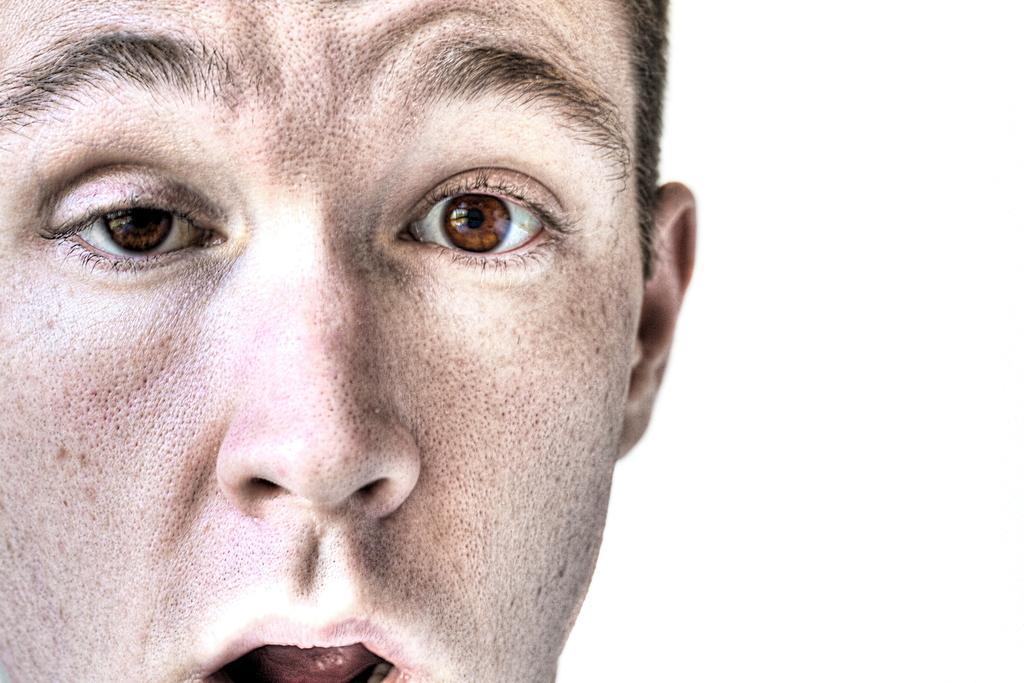Could you give a brief overview of what you see in this image? In this image I can see a person's face. The background is white in color. This image is taken may be in a room. 